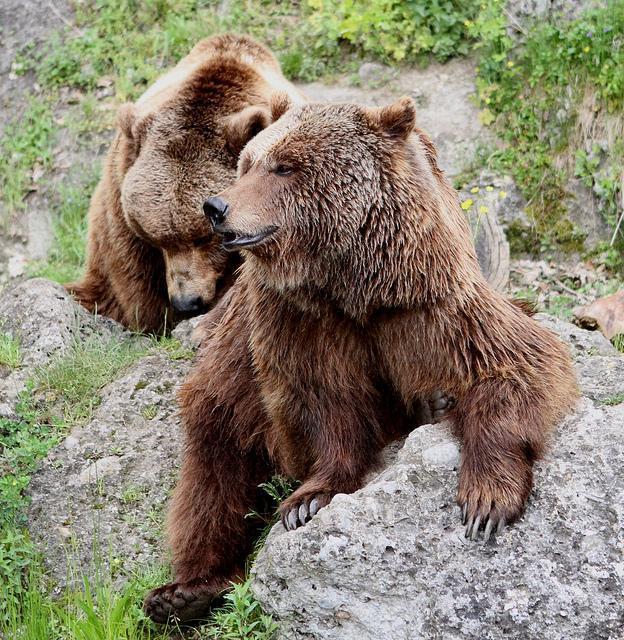How many bears are on the rock?
Give a very brief answer. 2. How many bears are there?
Give a very brief answer. 2. 